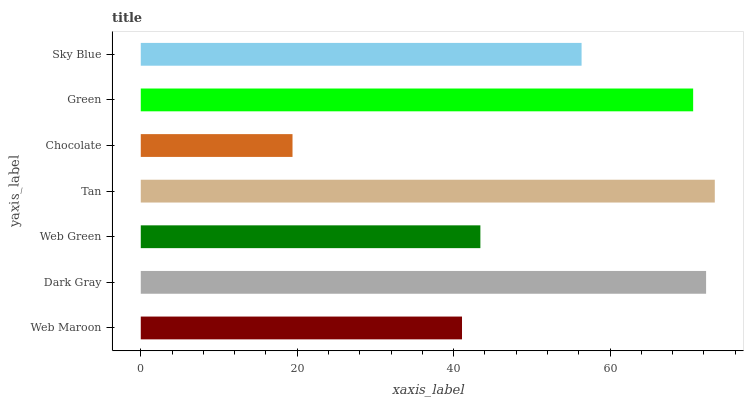Is Chocolate the minimum?
Answer yes or no. Yes. Is Tan the maximum?
Answer yes or no. Yes. Is Dark Gray the minimum?
Answer yes or no. No. Is Dark Gray the maximum?
Answer yes or no. No. Is Dark Gray greater than Web Maroon?
Answer yes or no. Yes. Is Web Maroon less than Dark Gray?
Answer yes or no. Yes. Is Web Maroon greater than Dark Gray?
Answer yes or no. No. Is Dark Gray less than Web Maroon?
Answer yes or no. No. Is Sky Blue the high median?
Answer yes or no. Yes. Is Sky Blue the low median?
Answer yes or no. Yes. Is Web Maroon the high median?
Answer yes or no. No. Is Green the low median?
Answer yes or no. No. 